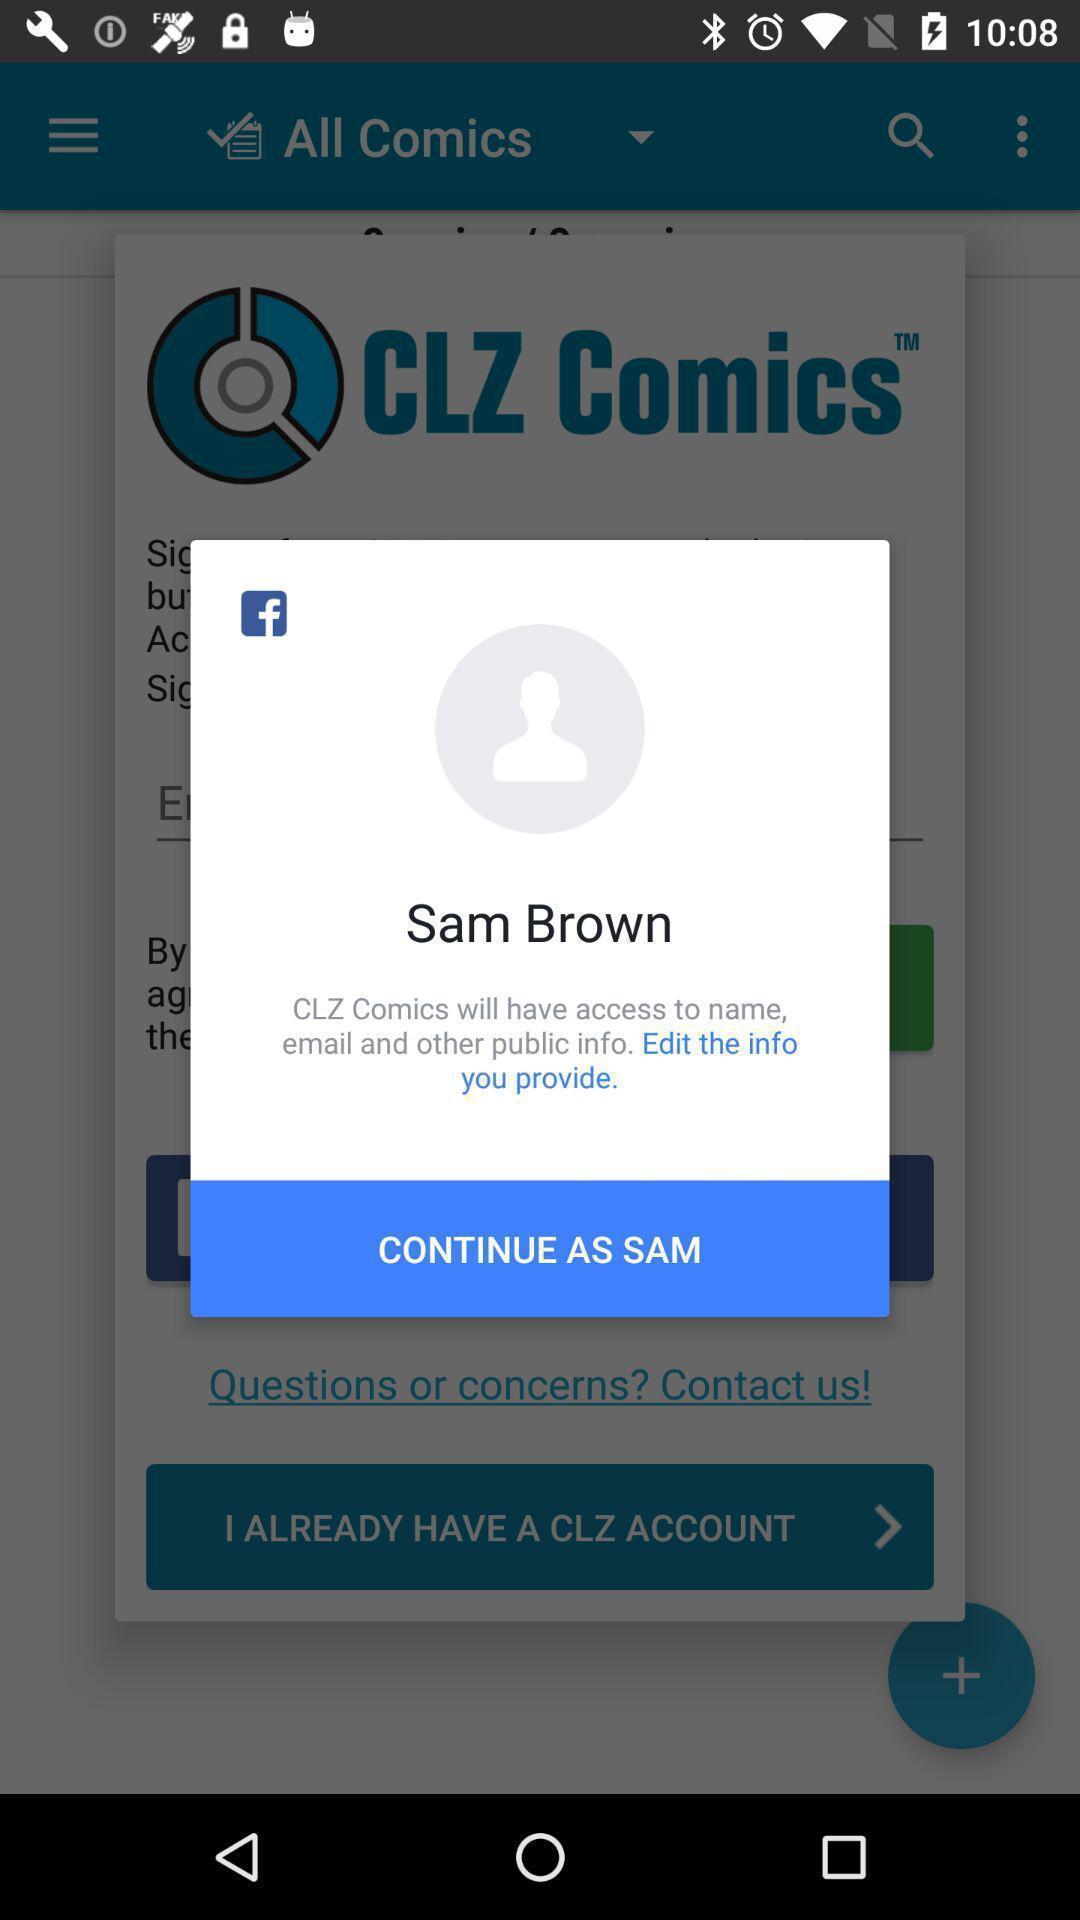Provide a textual representation of this image. Popup showing about profile and to continue. 